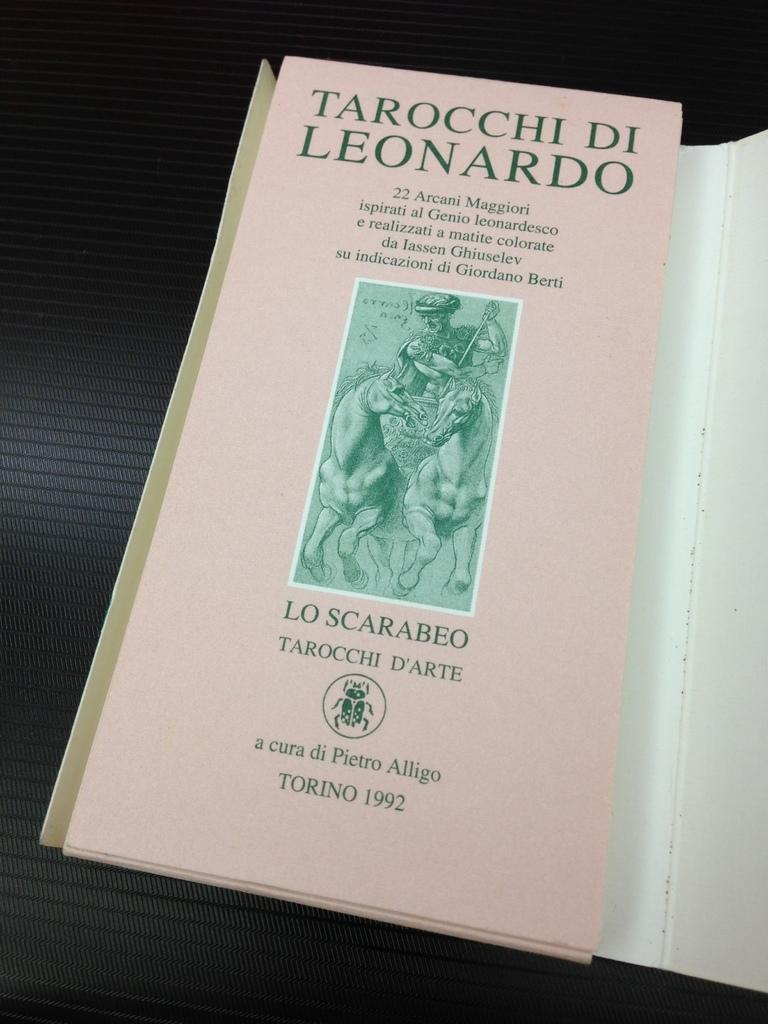<image>
Summarize the visual content of the image. A book titled Taraocchi DI Leonardo with a picture of the fighter with his horse on the cover. 